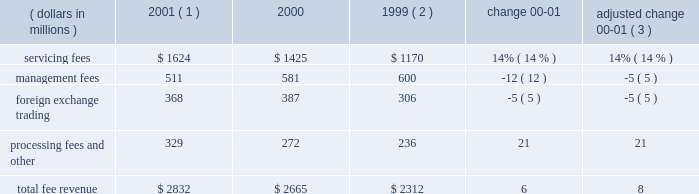An average of 7.1 in 2000 .
The top 100 largest clients used an average of 11.3 products in 2001 , up from an average of 11.2 in 2000 .
State street benefits significantly from its ability to derive revenue from the transaction flows of clients .
This occurs through the management of cash positions , including deposit balances and other short-term investment activities , using state street 2019s balance sheet capacity .
Significant foreign currency transaction volumes provide potential for foreign exchange trading revenue as well .
Fee revenue total operating fee revenuewas $ 2.8 billion in 2001 , compared to $ 2.7 billion in 2000 , an increase of 6% ( 6 % ) .
Adjusted for the formation of citistreet , the growth in fee revenue was 8% ( 8 % ) .
Growth in servicing fees of $ 199million , or 14% ( 14 % ) , was the primary contributor to the increase in fee revenue .
This growth primarily reflects several large client wins installed starting in the latter half of 2000 and continuing throughout 2001 , and strength in fee revenue from securities lending .
Declines in equity market values worldwide offset some of the growth in servicing fees .
Management fees were down 5% ( 5 % ) , adjusted for the formation of citistreet , reflecting the decline in theworldwide equitymarkets .
Foreign exchange trading revenue was down 5% ( 5 % ) , reflecting lower currency volatility , and processing fees and other revenue was up 21% ( 21 % ) , primarily due to gains on the sales of investment securities .
Servicing and management fees are a function of several factors , including the mix and volume of assets under custody and assets under management , securities positions held , and portfolio transactions , as well as types of products and services used by clients .
State street estimates , based on a study conducted in 2000 , that a 10% ( 10 % ) increase or decrease in worldwide equity values would cause a corresponding change in state street 2019s total revenue of approximately 2% ( 2 % ) .
If bond values were to increase or decrease by 10% ( 10 % ) , state street would anticipate a corresponding change of approximately 1% ( 1 % ) in its total revenue .
Securities lending revenue in 2001 increased approximately 40% ( 40 % ) over 2000 .
Securities lending revenue is reflected in both servicing fees and management fees .
Securities lending revenue is a function of the volume of securities lent and interest rate spreads .
While volumes increased in 2001 , the year-over-year increase is primarily due to wider interest rate spreads resulting from the unusual occurrence of eleven reductions in the u.s .
Federal funds target rate during 2001 .
F e e r e v e n u e ( dollars in millions ) 2001 ( 1 ) 2000 1999 ( 2 ) change adjusted change 00-01 ( 3 ) .
( 1 ) 2001 results exclude the write-off of state street 2019s total investment in bridge of $ 50 million ( 2 ) 1999 results exclude the one-time charge of $ 57 million related to the repositioning of the investment portfolio ( 3 ) 2000 results adjusted for the formation of citistreet 4 state street corporation .
What is the growth rate in total fee revenue in 2001? 
Computations: ((2832 - 2665) / 2665)
Answer: 0.06266. 